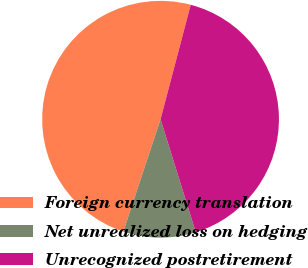Convert chart to OTSL. <chart><loc_0><loc_0><loc_500><loc_500><pie_chart><fcel>Foreign currency translation<fcel>Net unrealized loss on hedging<fcel>Unrecognized postretirement<nl><fcel>49.01%<fcel>9.9%<fcel>41.09%<nl></chart> 